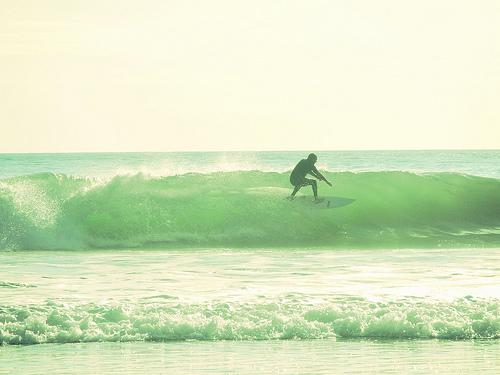Question: who does the person appear to be?
Choices:
A. A woman.
B. Grandma.
C. Male.
D. Mother.
Answer with the letter. Answer: C Question: how does the surfer come in to shore?
Choices:
A. On waves.
B. Walk.
C. Run.
D. Stroll.
Answer with the letter. Answer: A Question: why is person in crouched position?
Choices:
A. Picking up something.
B. Fell.
C. Tie shoe.
D. Balancing.
Answer with the letter. Answer: D Question: what is the person doing in water?
Choices:
A. Surfing.
B. Swimming.
C. Playing.
D. Walking.
Answer with the letter. Answer: A Question: when could this photo have been taken?
Choices:
A. Evening.
B. Winter.
C. Morning.
D. Night.
Answer with the letter. Answer: C Question: what is the person standing on?
Choices:
A. Ground.
B. Grass.
C. Cement.
D. Surfboard.
Answer with the letter. Answer: D 